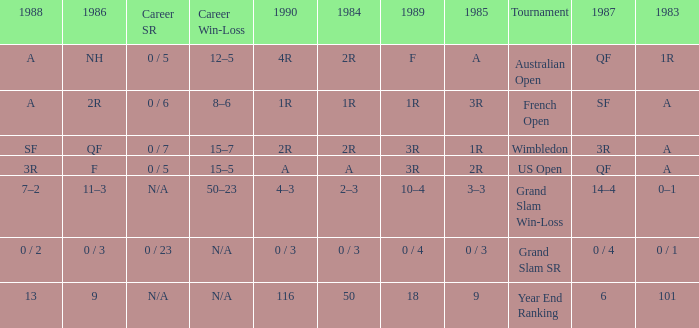With a 1986 of NH and a career SR of 0 / 5 what is the results in 1985? A. 